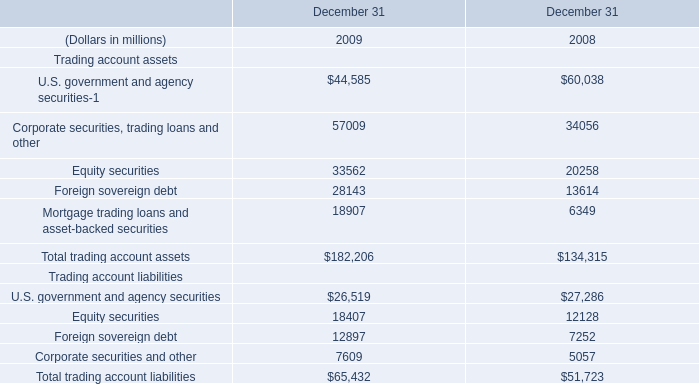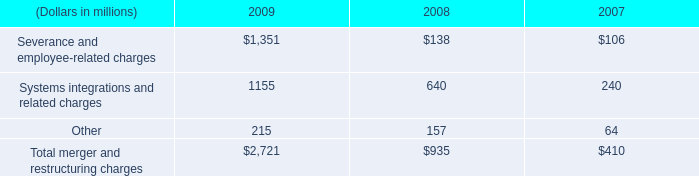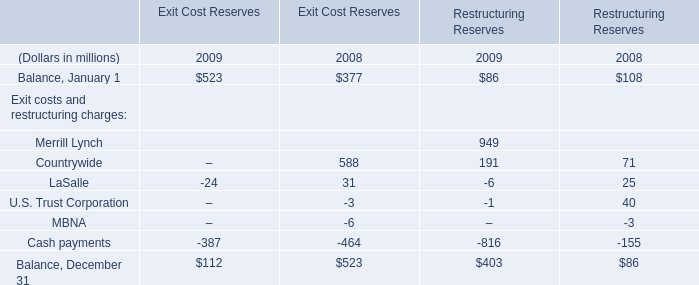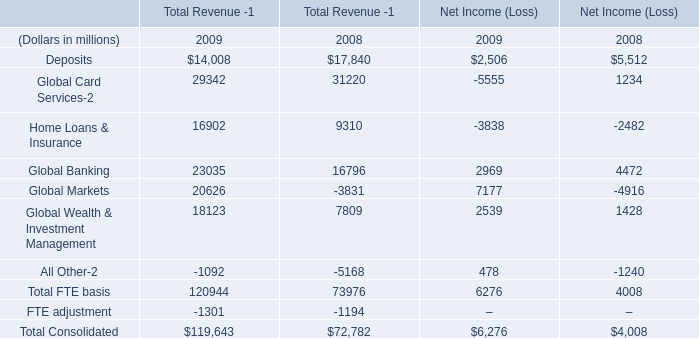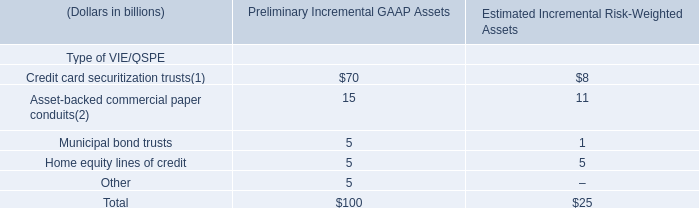What's the average of the Total trading account assets and Total trading account liabilities in the years where Total trading account assets is positive? (in million) 
Computations: ((182206 + 65432) / 2)
Answer: 123819.0. 